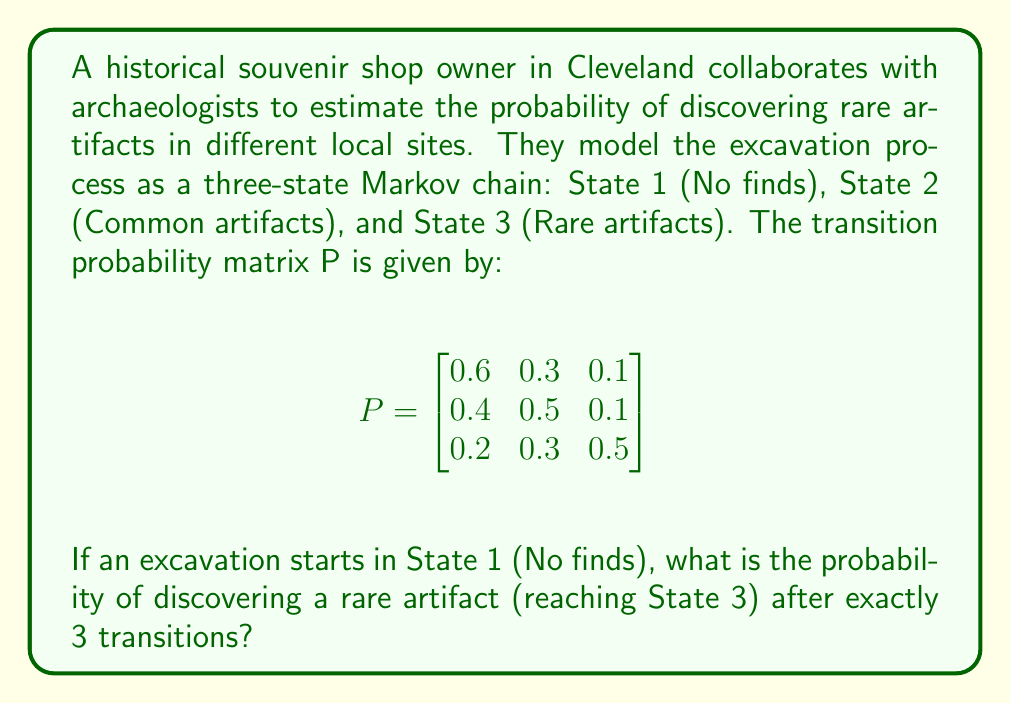Can you solve this math problem? To solve this problem, we need to calculate the probability of reaching State 3 from State 1 in exactly 3 steps using the given transition probability matrix.

Step 1: Calculate $P^3$ (the transition matrix for 3 steps)
We need to multiply the matrix P by itself three times:

$$P^3 = P \times P \times P$$

Using matrix multiplication (which can be done using a calculator or computer), we get:

$$P^3 = \begin{bmatrix}
0.456 & 0.372 & 0.172 \\
0.440 & 0.384 & 0.176 \\
0.336 & 0.372 & 0.292
\end{bmatrix}$$

Step 2: Interpret the result
The entry in the first row, third column of $P^3$ gives the probability of starting in State 1 and ending in State 3 after exactly 3 transitions.

From the calculated $P^3$, we can see that this probability is 0.172.

Therefore, the probability of discovering a rare artifact (reaching State 3) after exactly 3 transitions, starting from State 1, is 0.172 or 17.2%.
Answer: 0.172 